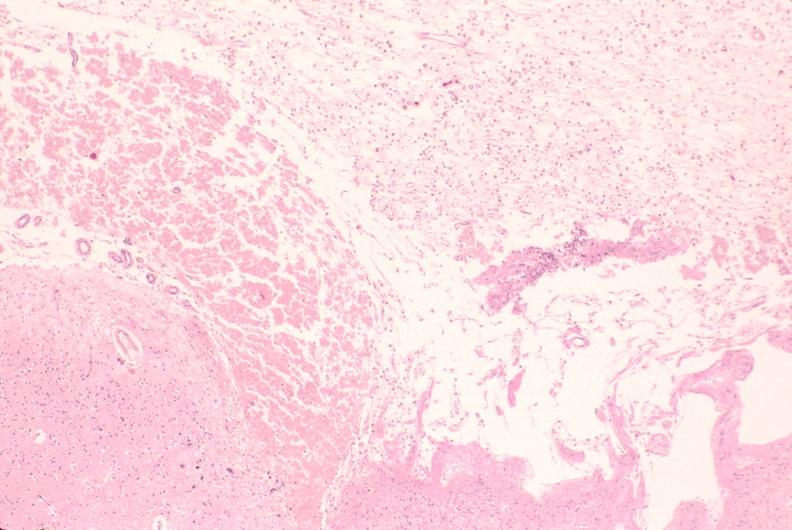where is this?
Answer the question using a single word or phrase. Nervous 